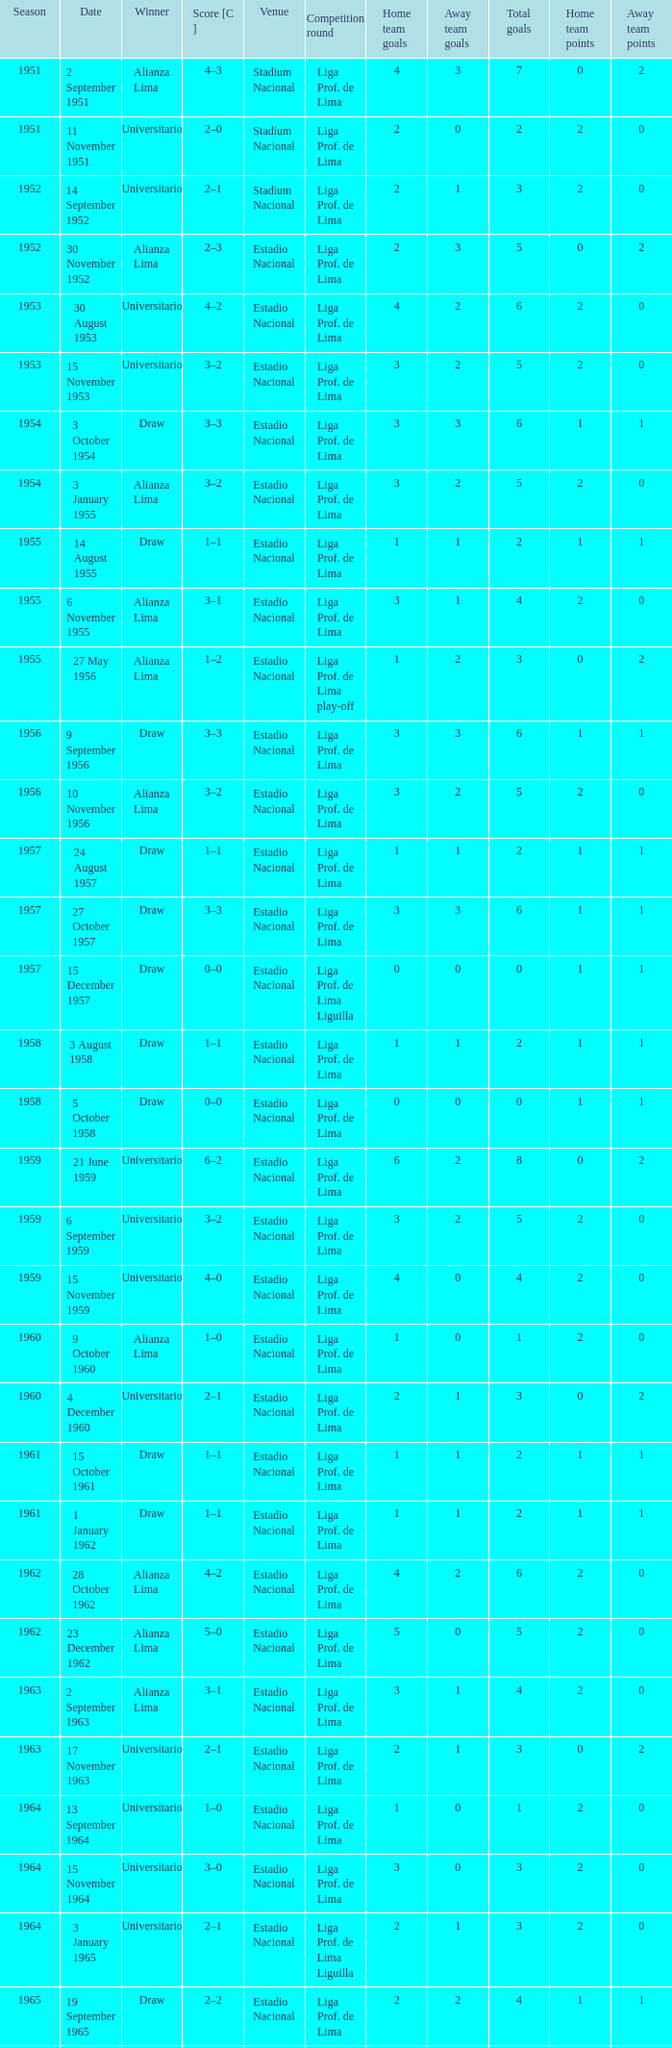What venue had an event on 17 November 1963? Estadio Nacional. 